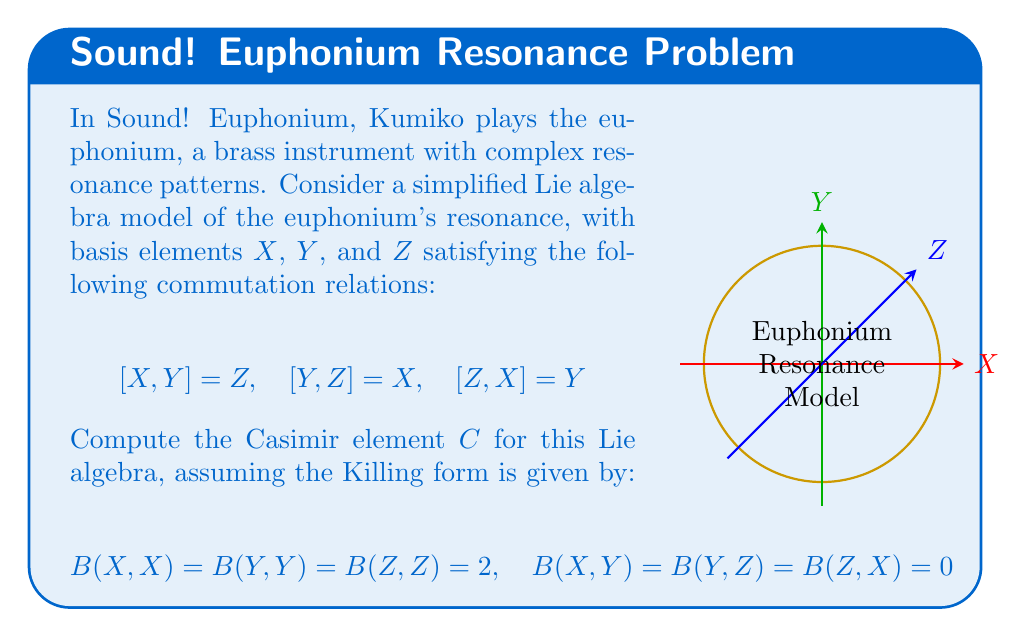Show me your answer to this math problem. Let's approach this step-by-step:

1) The Casimir element $C$ is defined as:

   $$C = \sum_{i,j} B^{ij} e_i e_j$$

   where $B^{ij}$ is the inverse of the matrix representation of the Killing form, and $e_i$ are the basis elements.

2) First, let's write out the matrix representation of the Killing form:

   $$B = \begin{pmatrix}
   2 & 0 & 0 \\
   0 & 2 & 0 \\
   0 & 0 & 2
   \end{pmatrix}$$

3) The inverse of this matrix is:

   $$B^{-1} = \begin{pmatrix}
   1/2 & 0 & 0 \\
   0 & 1/2 & 0 \\
   0 & 0 & 1/2
   \end{pmatrix}$$

4) Now, we can write out the Casimir element:

   $$C = \frac{1}{2}(X^2 + Y^2 + Z^2)$$

5) However, we need to be careful about the order of these terms, as they don't commute. We can use the symmetrized product:

   $$C = \frac{1}{4}(X^2 + Y^2 + Z^2 + XY + YX + YZ + ZY + ZX + XZ)$$

6) Using the commutation relations, we can simplify this:

   $$XY = YX + Z$$
   $$YZ = ZY + X$$
   $$ZX = XZ + Y$$

7) Substituting these back in:

   $$C = \frac{1}{4}(X^2 + Y^2 + Z^2 + 2YX + Z + 2ZY + X + 2XZ + Y)$$

8) Simplifying:

   $$C = \frac{1}{4}(X^2 + Y^2 + Z^2 + 2XY + 2YZ + 2ZX + X + Y + Z)$$

This is the Casimir element for the given Lie algebra.
Answer: $$C = \frac{1}{4}(X^2 + Y^2 + Z^2 + 2XY + 2YZ + 2ZX + X + Y + Z)$$ 